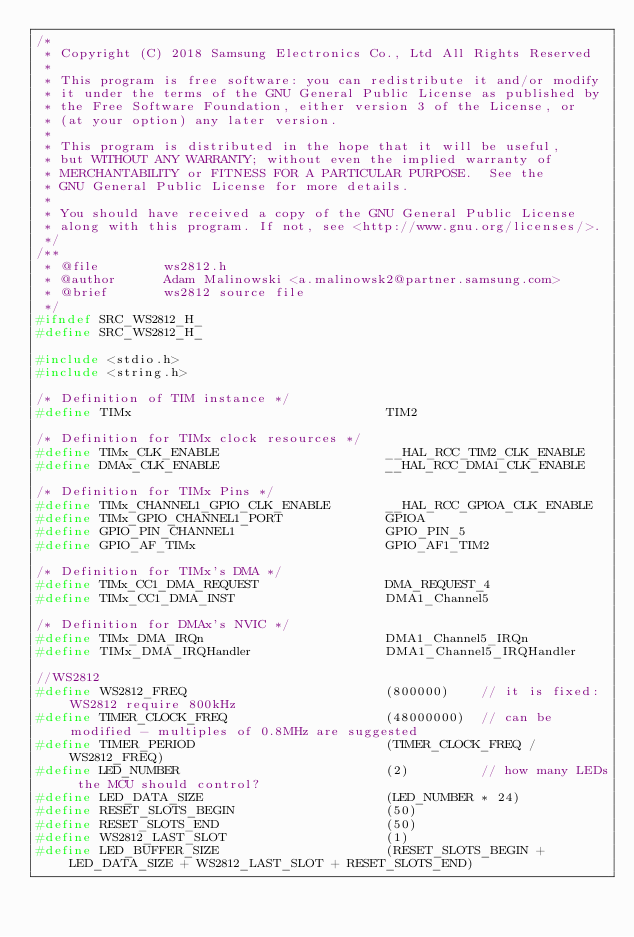Convert code to text. <code><loc_0><loc_0><loc_500><loc_500><_C_>/*
 * Copyright (C) 2018 Samsung Electronics Co., Ltd All Rights Reserved
 * 
 * This program is free software: you can redistribute it and/or modify
 * it under the terms of the GNU General Public License as published by
 * the Free Software Foundation, either version 3 of the License, or
 * (at your option) any later version.
 * 
 * This program is distributed in the hope that it will be useful,
 * but WITHOUT ANY WARRANTY; without even the implied warranty of
 * MERCHANTABILITY or FITNESS FOR A PARTICULAR PURPOSE.  See the
 * GNU General Public License for more details.
 * 
 * You should have received a copy of the GNU General Public License
 * along with this program. If not, see <http://www.gnu.org/licenses/>.
 */
/**
 * @file        ws2812.h
 * @author      Adam Malinowski <a.malinowsk2@partner.samsung.com>
 * @brief       ws2812 source file
 */
#ifndef SRC_WS2812_H_
#define SRC_WS2812_H_

#include <stdio.h>
#include <string.h>

/* Definition of TIM instance */
#define TIMx                                TIM2

/* Definition for TIMx clock resources */
#define TIMx_CLK_ENABLE                     __HAL_RCC_TIM2_CLK_ENABLE
#define DMAx_CLK_ENABLE                     __HAL_RCC_DMA1_CLK_ENABLE

/* Definition for TIMx Pins */
#define TIMx_CHANNEL1_GPIO_CLK_ENABLE       __HAL_RCC_GPIOA_CLK_ENABLE
#define TIMx_GPIO_CHANNEL1_PORT             GPIOA
#define GPIO_PIN_CHANNEL1                   GPIO_PIN_5
#define GPIO_AF_TIMx                        GPIO_AF1_TIM2

/* Definition for TIMx's DMA */
#define TIMx_CC1_DMA_REQUEST                DMA_REQUEST_4
#define TIMx_CC1_DMA_INST                   DMA1_Channel5

/* Definition for DMAx's NVIC */
#define TIMx_DMA_IRQn                       DMA1_Channel5_IRQn
#define TIMx_DMA_IRQHandler                 DMA1_Channel5_IRQHandler

//WS2812
#define WS2812_FREQ                         (800000)    // it is fixed: WS2812 require 800kHz
#define TIMER_CLOCK_FREQ                    (48000000)  // can be modified - multiples of 0.8MHz are suggested
#define TIMER_PERIOD                        (TIMER_CLOCK_FREQ / WS2812_FREQ)
#define LED_NUMBER                          (2)         // how many LEDs the MCU should control?
#define LED_DATA_SIZE                       (LED_NUMBER * 24)
#define RESET_SLOTS_BEGIN                   (50)
#define RESET_SLOTS_END                     (50)
#define WS2812_LAST_SLOT                    (1)
#define LED_BUFFER_SIZE                     (RESET_SLOTS_BEGIN + LED_DATA_SIZE + WS2812_LAST_SLOT + RESET_SLOTS_END)</code> 